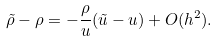<formula> <loc_0><loc_0><loc_500><loc_500>\tilde { \rho } - \rho = - \frac { \rho } { u } ( \tilde { u } - u ) + O ( h ^ { 2 } ) .</formula> 